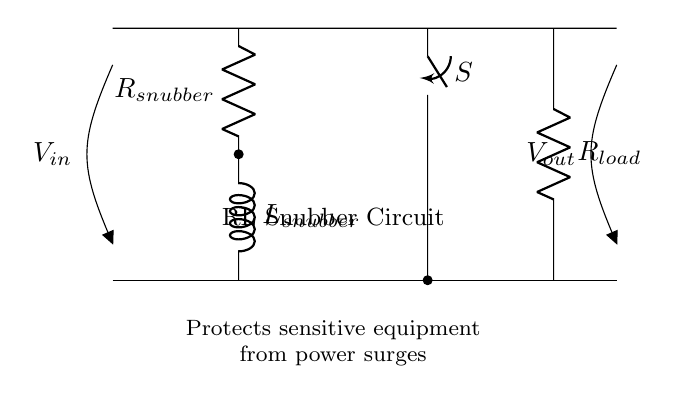What is the input voltage of the circuit? The input voltage is denoted by \( V_{in} \), which is the voltage applied at the input terminal of the circuit.
Answer: \( V_{in} \) What is the role of the resistor in this circuit? The resistor \( R_{snubber} \) is in series with the inductor and helps to limit the rate of current change, providing a damping effect to prevent excessive voltage spikes.
Answer: Damping How many components make up the RL snubber circuit? The RL snubber circuit consists of three main components: one resistor, one inductor, and one switch.
Answer: Three What is the voltage across the output? The output voltage is denoted by \( V_{out} \), indicating the voltage present at the output terminal of the circuit.
Answer: \( V_{out} \) Why is there a switch in this circuit? The switch \( S \) allows for the control of the circuit, enabling or disabling the snubbing process depending on whether the switch is open or closed.
Answer: Control Which component is responsible for protecting sensitive electronics? The combination of the resistor \( R_{snubber} \) and the inductor \( L_{snubber} \) functions as the protection mechanism against power surges.
Answer: RL snubber What does the RL snubber circuit primarily protect against? It primarily protects against power surges that can occur in areas with unreliable electricity supply.
Answer: Power surges 